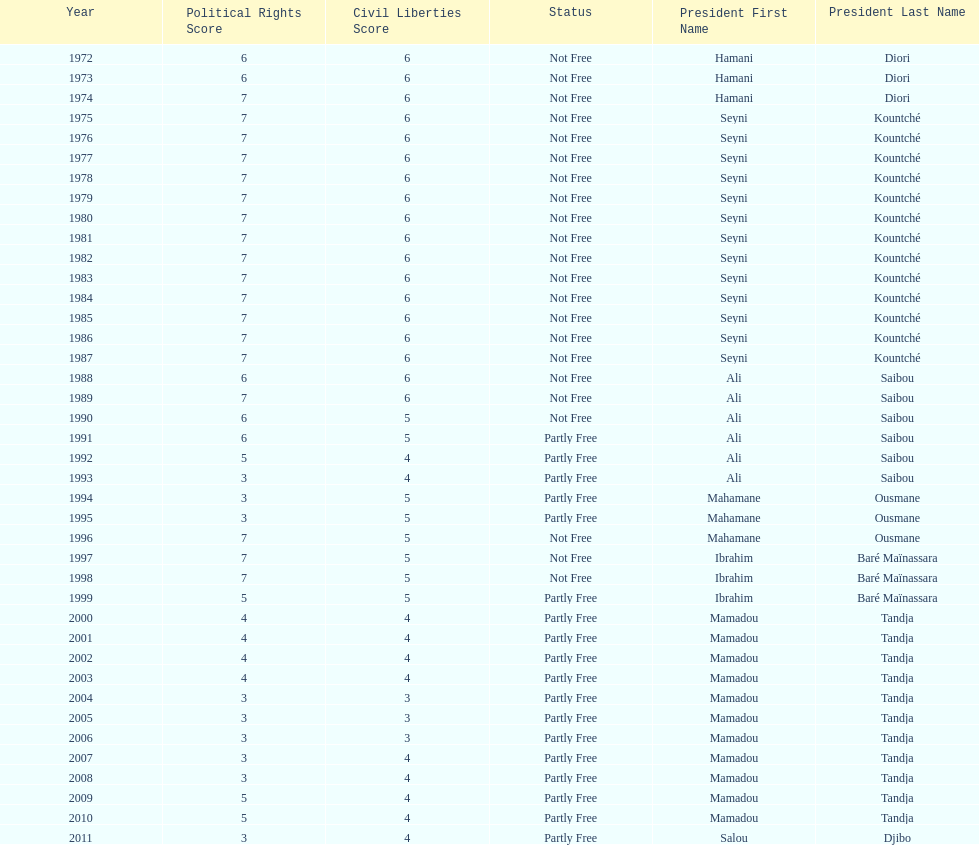Help me parse the entirety of this table. {'header': ['Year', 'Political Rights Score', 'Civil Liberties Score', 'Status', 'President First Name', 'President Last Name'], 'rows': [['1972', '6', '6', 'Not Free', 'Hamani', 'Diori'], ['1973', '6', '6', 'Not Free', 'Hamani', 'Diori'], ['1974', '7', '6', 'Not Free', 'Hamani', 'Diori'], ['1975', '7', '6', 'Not Free', 'Seyni', 'Kountché'], ['1976', '7', '6', 'Not Free', 'Seyni', 'Kountché'], ['1977', '7', '6', 'Not Free', 'Seyni', 'Kountché'], ['1978', '7', '6', 'Not Free', 'Seyni', 'Kountché'], ['1979', '7', '6', 'Not Free', 'Seyni', 'Kountché'], ['1980', '7', '6', 'Not Free', 'Seyni', 'Kountché'], ['1981', '7', '6', 'Not Free', 'Seyni', 'Kountché'], ['1982', '7', '6', 'Not Free', 'Seyni', 'Kountché'], ['1983', '7', '6', 'Not Free', 'Seyni', 'Kountché'], ['1984', '7', '6', 'Not Free', 'Seyni', 'Kountché'], ['1985', '7', '6', 'Not Free', 'Seyni', 'Kountché'], ['1986', '7', '6', 'Not Free', 'Seyni', 'Kountché'], ['1987', '7', '6', 'Not Free', 'Seyni', 'Kountché'], ['1988', '6', '6', 'Not Free', 'Ali', 'Saibou'], ['1989', '7', '6', 'Not Free', 'Ali', 'Saibou'], ['1990', '6', '5', 'Not Free', 'Ali', 'Saibou'], ['1991', '6', '5', 'Partly Free', 'Ali', 'Saibou'], ['1992', '5', '4', 'Partly Free', 'Ali', 'Saibou'], ['1993', '3', '4', 'Partly Free', 'Ali', 'Saibou'], ['1994', '3', '5', 'Partly Free', 'Mahamane', 'Ousmane'], ['1995', '3', '5', 'Partly Free', 'Mahamane', 'Ousmane'], ['1996', '7', '5', 'Not Free', 'Mahamane', 'Ousmane'], ['1997', '7', '5', 'Not Free', 'Ibrahim', 'Baré Maïnassara'], ['1998', '7', '5', 'Not Free', 'Ibrahim', 'Baré Maïnassara'], ['1999', '5', '5', 'Partly Free', 'Ibrahim', 'Baré Maïnassara'], ['2000', '4', '4', 'Partly Free', 'Mamadou', 'Tandja'], ['2001', '4', '4', 'Partly Free', 'Mamadou', 'Tandja'], ['2002', '4', '4', 'Partly Free', 'Mamadou', 'Tandja'], ['2003', '4', '4', 'Partly Free', 'Mamadou', 'Tandja'], ['2004', '3', '3', 'Partly Free', 'Mamadou', 'Tandja'], ['2005', '3', '3', 'Partly Free', 'Mamadou', 'Tandja'], ['2006', '3', '3', 'Partly Free', 'Mamadou', 'Tandja'], ['2007', '3', '4', 'Partly Free', 'Mamadou', 'Tandja'], ['2008', '3', '4', 'Partly Free', 'Mamadou', 'Tandja'], ['2009', '5', '4', 'Partly Free', 'Mamadou', 'Tandja'], ['2010', '5', '4', 'Partly Free', 'Mamadou', 'Tandja'], ['2011', '3', '4', 'Partly Free', 'Salou', 'Djibo']]} How many times was the political rights listed as seven? 18. 